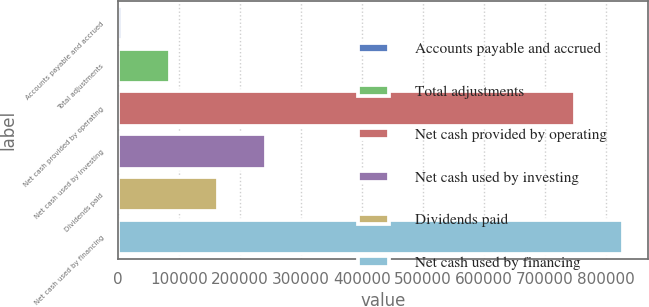Convert chart. <chart><loc_0><loc_0><loc_500><loc_500><bar_chart><fcel>Accounts payable and accrued<fcel>Total adjustments<fcel>Net cash provided by operating<fcel>Net cash used by investing<fcel>Dividends paid<fcel>Net cash used by financing<nl><fcel>6368<fcel>85158.7<fcel>748488<fcel>242740<fcel>163949<fcel>827279<nl></chart> 